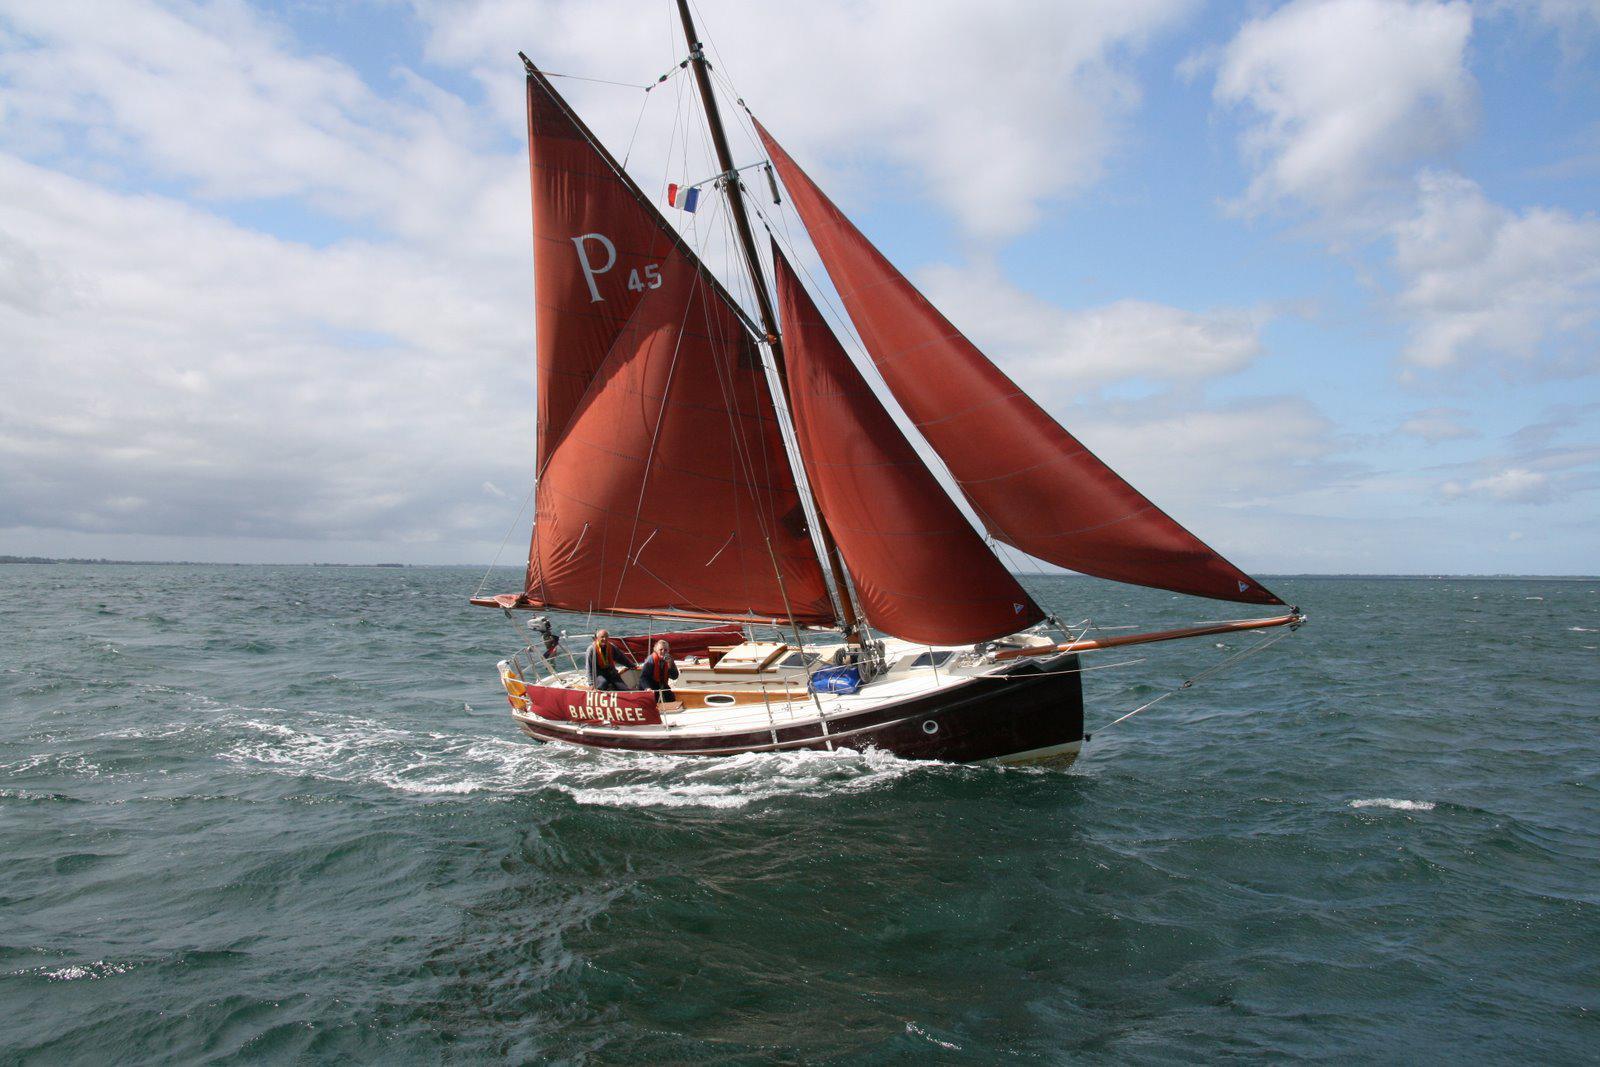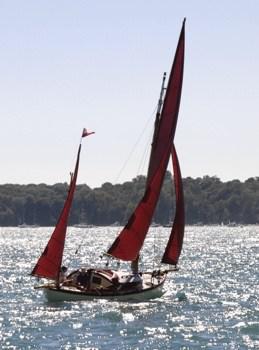The first image is the image on the left, the second image is the image on the right. Given the left and right images, does the statement "The left and right image contains the same number of sailboats with a dark open sails." hold true? Answer yes or no. Yes. The first image is the image on the left, the second image is the image on the right. Analyze the images presented: Is the assertion "The sailboats in the left and right images each have unfurled sails that are colored instead of white." valid? Answer yes or no. Yes. 